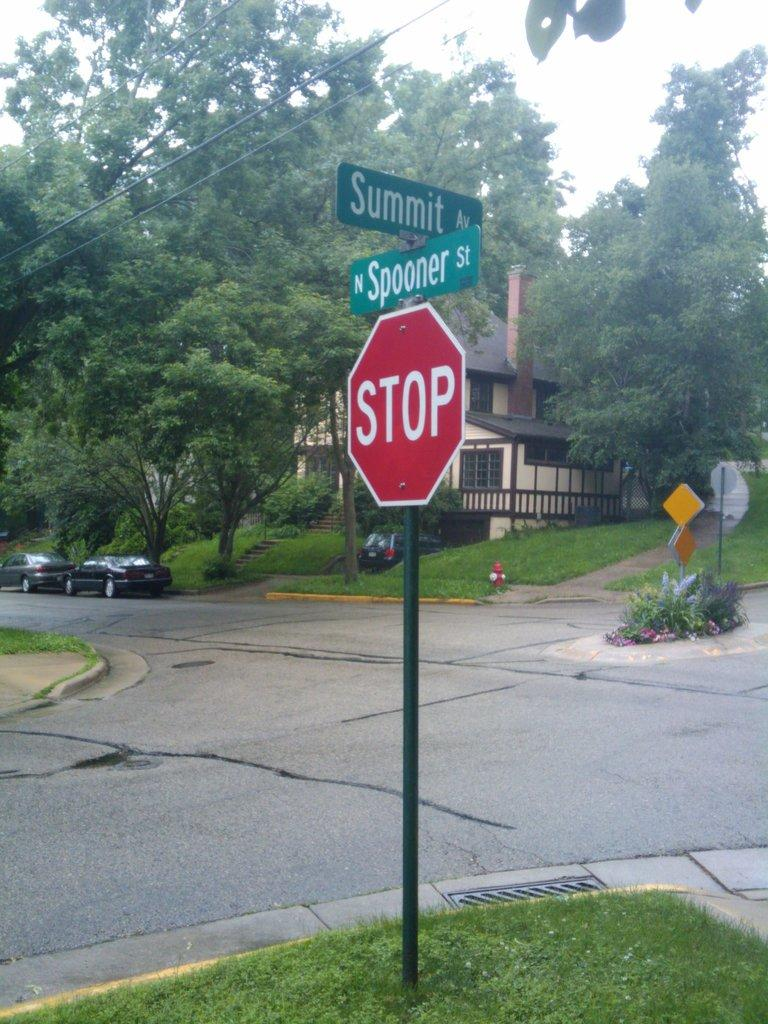What type of structures can be seen in the image? There are houses in the image. What else can be seen beside the road in the image? Vehicles are parked beside the road in the image. Where are the sign boards located in the image? The sign boards are on the grass in the image. What type of vegetation is visible in the image? Trees are visible in the image. What type of ground cover is present in the image? Grass is present in the image. What color are the beads used to decorate the trousers in the image? There are no beads or trousers present in the image. How many town halls can be seen in the image? There is no town hall depicted in the image; it features houses, vehicles, sign boards, trees, and grass. 